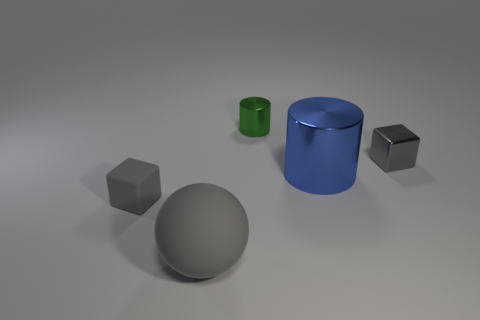Subtract all spheres. How many objects are left? 4 Add 2 small shiny balls. How many objects exist? 7 Subtract 1 cylinders. How many cylinders are left? 1 Subtract all gray cylinders. Subtract all green cubes. How many cylinders are left? 2 Subtract all brown blocks. How many red cylinders are left? 0 Subtract all tiny metallic cylinders. Subtract all big spheres. How many objects are left? 3 Add 3 large matte balls. How many large matte balls are left? 4 Add 5 small gray rubber things. How many small gray rubber things exist? 6 Subtract 0 gray cylinders. How many objects are left? 5 